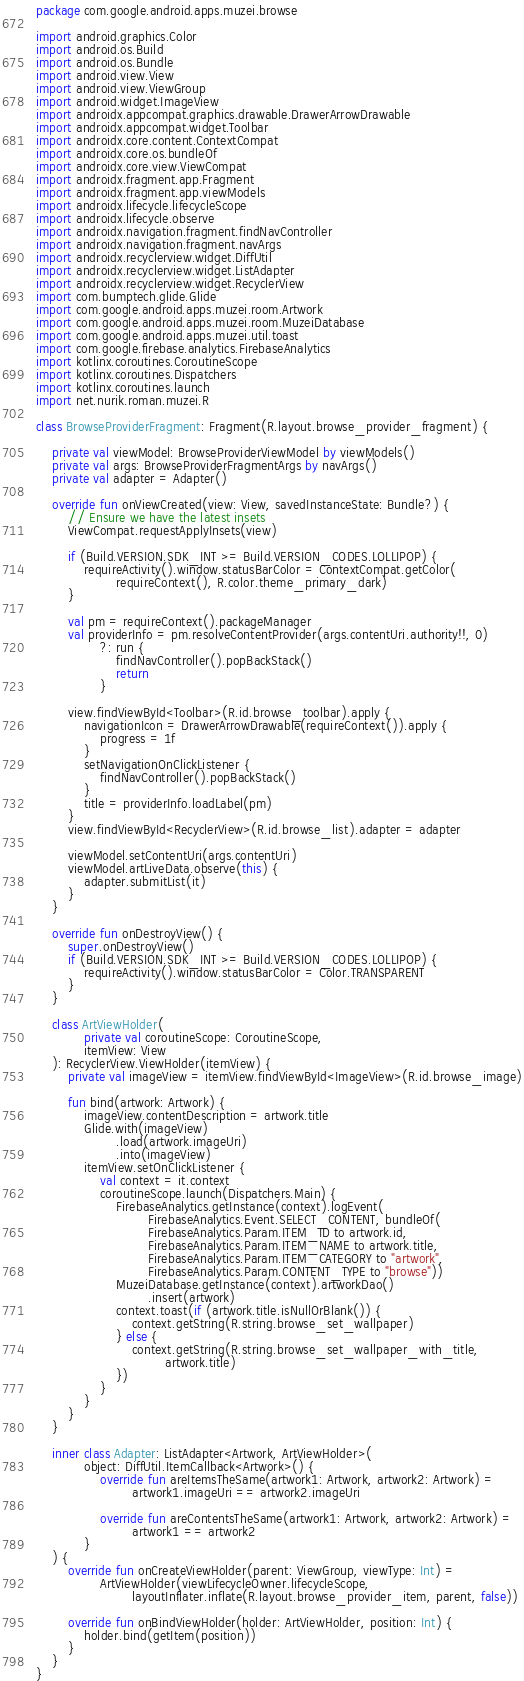<code> <loc_0><loc_0><loc_500><loc_500><_Kotlin_>package com.google.android.apps.muzei.browse

import android.graphics.Color
import android.os.Build
import android.os.Bundle
import android.view.View
import android.view.ViewGroup
import android.widget.ImageView
import androidx.appcompat.graphics.drawable.DrawerArrowDrawable
import androidx.appcompat.widget.Toolbar
import androidx.core.content.ContextCompat
import androidx.core.os.bundleOf
import androidx.core.view.ViewCompat
import androidx.fragment.app.Fragment
import androidx.fragment.app.viewModels
import androidx.lifecycle.lifecycleScope
import androidx.lifecycle.observe
import androidx.navigation.fragment.findNavController
import androidx.navigation.fragment.navArgs
import androidx.recyclerview.widget.DiffUtil
import androidx.recyclerview.widget.ListAdapter
import androidx.recyclerview.widget.RecyclerView
import com.bumptech.glide.Glide
import com.google.android.apps.muzei.room.Artwork
import com.google.android.apps.muzei.room.MuzeiDatabase
import com.google.android.apps.muzei.util.toast
import com.google.firebase.analytics.FirebaseAnalytics
import kotlinx.coroutines.CoroutineScope
import kotlinx.coroutines.Dispatchers
import kotlinx.coroutines.launch
import net.nurik.roman.muzei.R

class BrowseProviderFragment: Fragment(R.layout.browse_provider_fragment) {

    private val viewModel: BrowseProviderViewModel by viewModels()
    private val args: BrowseProviderFragmentArgs by navArgs()
    private val adapter = Adapter()

    override fun onViewCreated(view: View, savedInstanceState: Bundle?) {
        // Ensure we have the latest insets
        ViewCompat.requestApplyInsets(view)

        if (Build.VERSION.SDK_INT >= Build.VERSION_CODES.LOLLIPOP) {
            requireActivity().window.statusBarColor = ContextCompat.getColor(
                    requireContext(), R.color.theme_primary_dark)
        }

        val pm = requireContext().packageManager
        val providerInfo = pm.resolveContentProvider(args.contentUri.authority!!, 0)
                ?: run {
                    findNavController().popBackStack()
                    return
                }

        view.findViewById<Toolbar>(R.id.browse_toolbar).apply {
            navigationIcon = DrawerArrowDrawable(requireContext()).apply {
                progress = 1f
            }
            setNavigationOnClickListener {
                findNavController().popBackStack()
            }
            title = providerInfo.loadLabel(pm)
        }
        view.findViewById<RecyclerView>(R.id.browse_list).adapter = adapter

        viewModel.setContentUri(args.contentUri)
        viewModel.artLiveData.observe(this) {
            adapter.submitList(it)
        }
    }

    override fun onDestroyView() {
        super.onDestroyView()
        if (Build.VERSION.SDK_INT >= Build.VERSION_CODES.LOLLIPOP) {
            requireActivity().window.statusBarColor = Color.TRANSPARENT
        }
    }

    class ArtViewHolder(
            private val coroutineScope: CoroutineScope,
            itemView: View
    ): RecyclerView.ViewHolder(itemView) {
        private val imageView = itemView.findViewById<ImageView>(R.id.browse_image)

        fun bind(artwork: Artwork) {
            imageView.contentDescription = artwork.title
            Glide.with(imageView)
                    .load(artwork.imageUri)
                    .into(imageView)
            itemView.setOnClickListener {
                val context = it.context
                coroutineScope.launch(Dispatchers.Main) {
                    FirebaseAnalytics.getInstance(context).logEvent(
                            FirebaseAnalytics.Event.SELECT_CONTENT, bundleOf(
                            FirebaseAnalytics.Param.ITEM_ID to artwork.id,
                            FirebaseAnalytics.Param.ITEM_NAME to artwork.title,
                            FirebaseAnalytics.Param.ITEM_CATEGORY to "artwork",
                            FirebaseAnalytics.Param.CONTENT_TYPE to "browse"))
                    MuzeiDatabase.getInstance(context).artworkDao()
                            .insert(artwork)
                    context.toast(if (artwork.title.isNullOrBlank()) {
                        context.getString(R.string.browse_set_wallpaper)
                    } else {
                        context.getString(R.string.browse_set_wallpaper_with_title,
                                artwork.title)
                    })
                }
            }
        }
    }

    inner class Adapter: ListAdapter<Artwork, ArtViewHolder>(
            object: DiffUtil.ItemCallback<Artwork>() {
                override fun areItemsTheSame(artwork1: Artwork, artwork2: Artwork) =
                        artwork1.imageUri == artwork2.imageUri

                override fun areContentsTheSame(artwork1: Artwork, artwork2: Artwork) =
                        artwork1 == artwork2
            }
    ) {
        override fun onCreateViewHolder(parent: ViewGroup, viewType: Int) =
                ArtViewHolder(viewLifecycleOwner.lifecycleScope,
                        layoutInflater.inflate(R.layout.browse_provider_item, parent, false))

        override fun onBindViewHolder(holder: ArtViewHolder, position: Int) {
            holder.bind(getItem(position))
        }
    }
}
</code> 